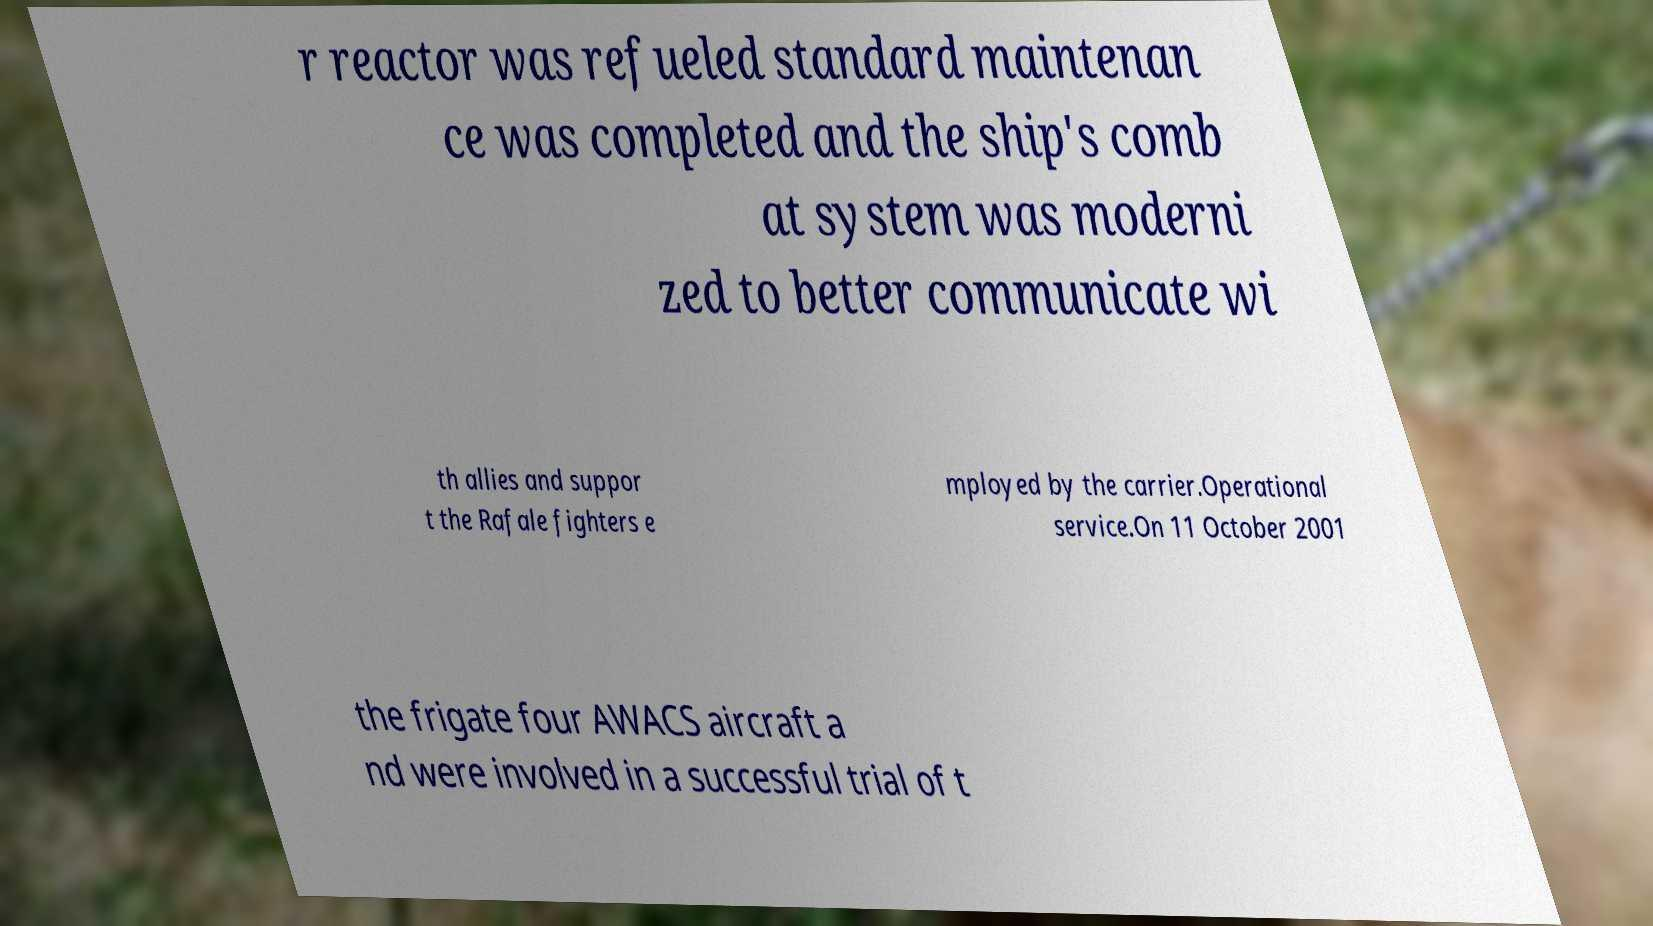Please identify and transcribe the text found in this image. r reactor was refueled standard maintenan ce was completed and the ship's comb at system was moderni zed to better communicate wi th allies and suppor t the Rafale fighters e mployed by the carrier.Operational service.On 11 October 2001 the frigate four AWACS aircraft a nd were involved in a successful trial of t 